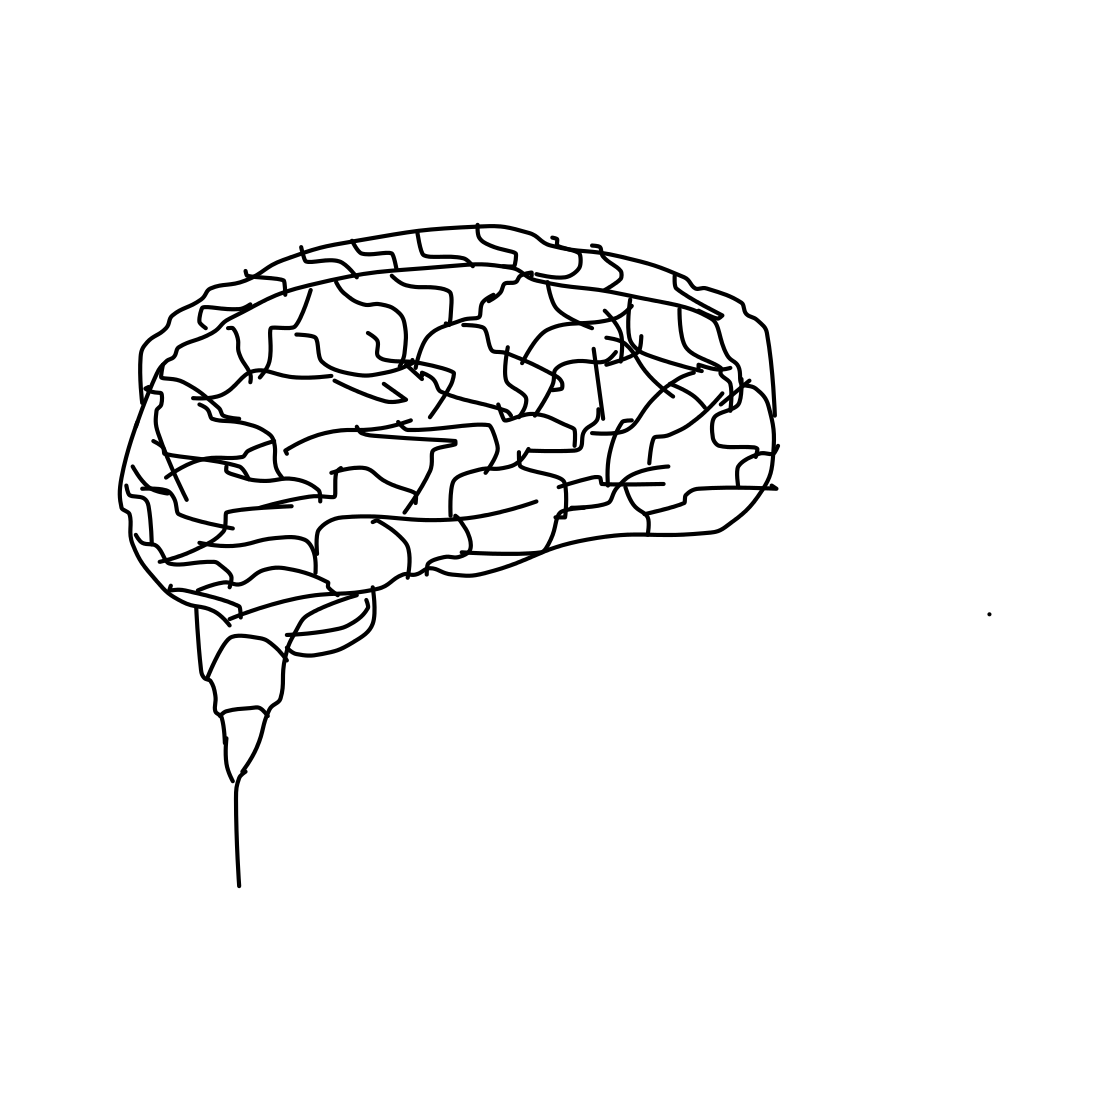In the scene, is a pen in it? No, there is no pen in the image. The image displays a simplified, line-drawing representation of a human brain, focusing on the visual depiction of brain sections and areas. 